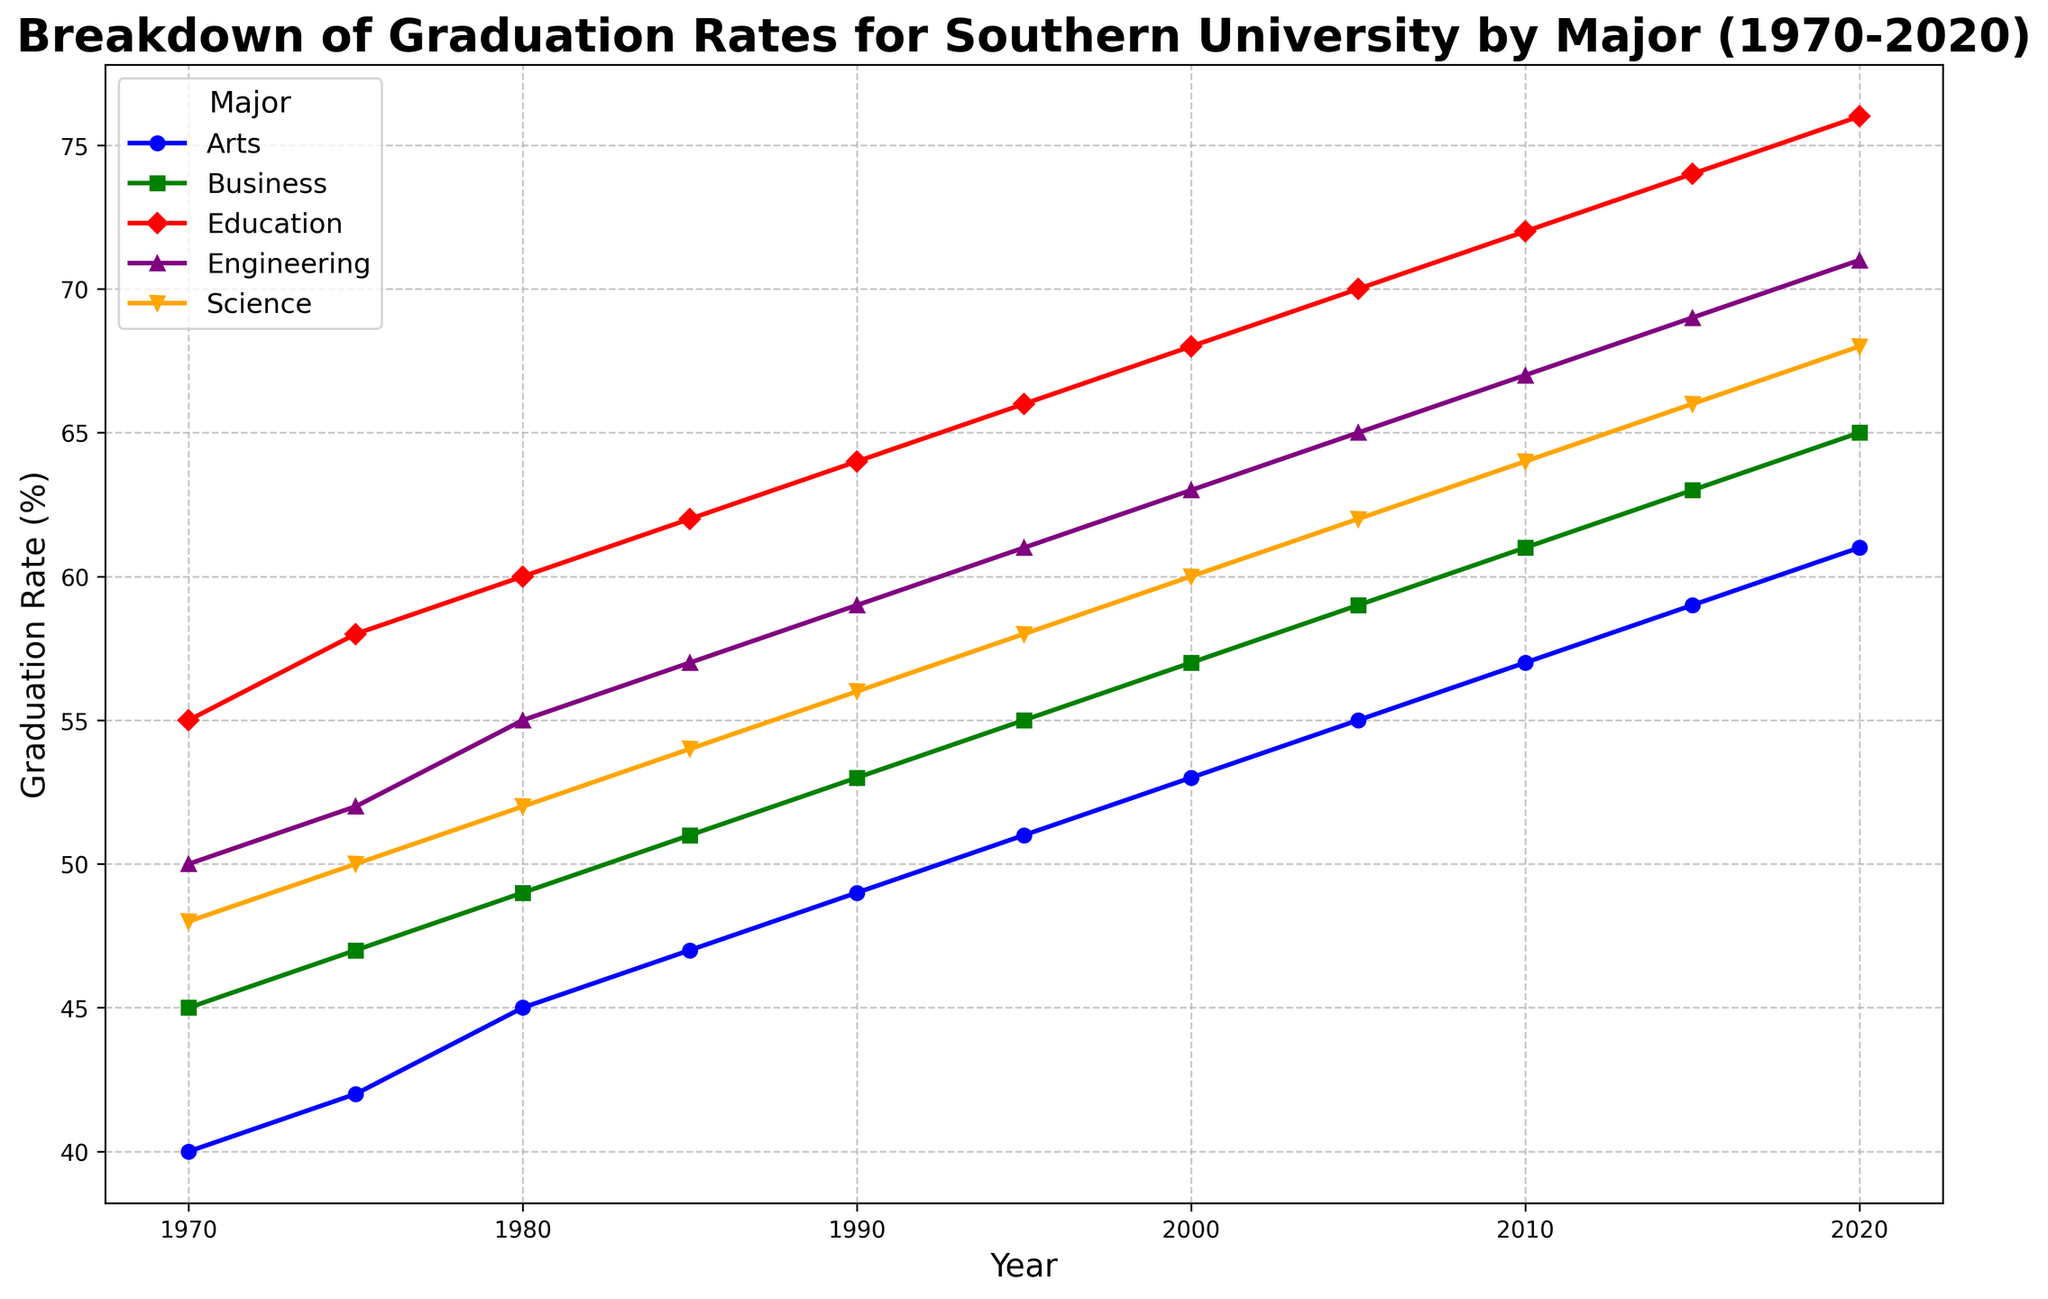What is the overall trend in graduation rates for Engineering from 1970 to 2020? The graph shows graduation rates for Engineering start at 50% in 1970 and gradually increase over the years, reaching 71% in 2020.
Answer: Increasing trend Which major had the highest graduation rate in 2020? The 2020 data points show Education with the highest rate, reaching 76%.
Answer: Education Which major had the lowest graduation rate in 1970? Observing the 1970 data points, Arts had the lowest graduation rate at 40%.
Answer: Arts By how much did the graduation rate for Business increase from 1970 to 2020? The Business graduation rate increased from 45% in 1970 to 65% in 2020. 65% - 45% = 20%.
Answer: 20% Which major had a consistent increase in graduation rates across all the years from 1970 to 2020? Analyzing the graph, Education shows a consistent increase in graduation rates every five years from 1970 (55%) to 2020 (76%).
Answer: Education What is the average graduation rate for Science between 1970 and 2020? The Science graduation rates at each interval are 48, 50, 52, 54, 56, 58, 60, 62, 64, 66, 68. Summing these up gives 638, and dividing by 11 intervals gives approximately 58%.
Answer: 58% Which major showed the sharpest increase in graduation rates between 1970 and 2020? Education increased from 55% in 1970 to 76% in 2020 (21% increase), the sharpest among all majors.
Answer: Education In which year did Arts have a 50% graduation rate? Analyzing the graph, Arts never hit exactly 50%; it was 49% in 1990 and 51% in 1995.
Answer: Never Compare the change in graduation rates for Business and Science from 1970 to 2020. Which saw a larger increase? Business increased from 45% in 1970 to 65% in 2020 (20% increase). Science increased from 48% in 1970 to 68% in 2020 (20% increase). Both saw the same increase.
Answer: Both saw the same increase What is the difference between the graduation rates for Engineering and Arts in 2020? Engineering had a graduation rate of 71% in 2020, while Arts had 61%. The difference is 71% - 61% = 10%.
Answer: 10% 